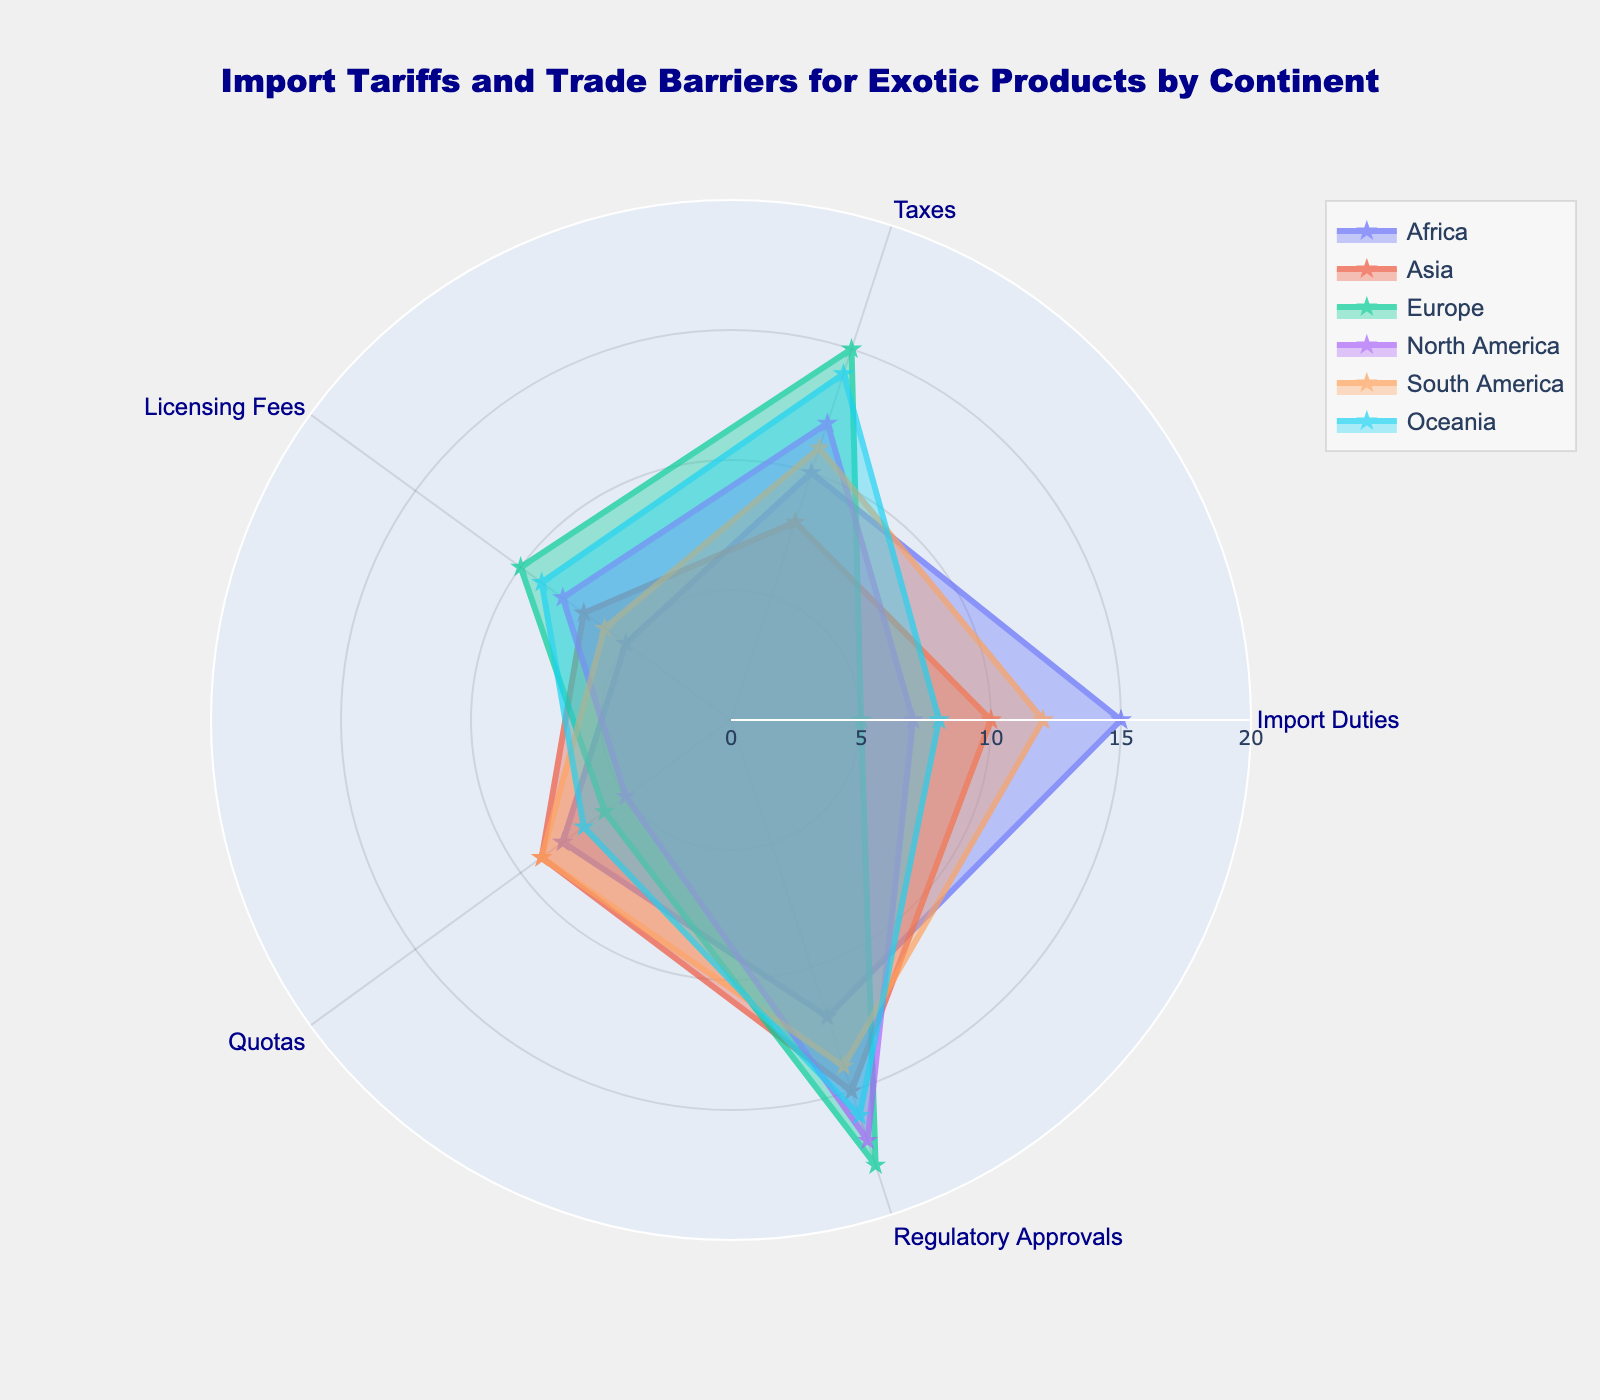What's the title of the radar chart? The title is usually located at the top of the figure. By reading the text there, we can identify it. The chart's title is: "Import Tariffs and Trade Barriers for Exotic Products by Continent".
Answer: Import Tariffs and Trade Barriers for Exotic Products by Continent Which continent has the highest Regulatory Approvals value? Look at the data points or lines corresponding to the Regulatory Approvals axis to see which continent's data reaches the highest value. Europe has the highest value at 18.
Answer: Europe How do Import Duties for Asia compare to those for Europe? Examine the axis corresponding to Import Duties and the values for both Asia and Europe. Asia has an Import Duties value of 10, while Europe has a value of 5. Thus, Asia has higher Import Duties than Europe.
Answer: Asia has higher duties What is the average of the Quotas values for all continents shown? Add up all the Quotas values (8 for Africa, 9 for Asia, 6 for Europe, 5 for North America, 9 for South America, and 7 for Oceania), then divide by the number of continents (6). (8 + 9 + 6 + 5 + 9 + 7) / 6 = 44 / 6 = 7.33.
Answer: 7.33 Which continent has the least variation among its values for all categories? Calculate the range (max value - min value) for each continent's data. Least variation will be the smallest range. Africa's values are 15, 10, 5, 8, 12; range is 10. Other ranges: Asia (8), Europe (13), North America (12), South America (5), Oceania (8). So, South America has the lowest variation.
Answer: South America How many categories does the radar chart display? Count the number of labels or spokes in the radar chart. They are Import Duties, Taxes, Licensing Fees, Quotas, and Regulatory Approvals. There are 5 categories.
Answer: 5 Between which two continents is the difference in Licensing Fees the greatest? Determine the Licensing Fees values for all continents: Africa (5), Asia (7), Europe (10), North America (8), South America (6), Oceania (9). The greatest difference is between Europe (10) and Africa (5), which is 5.
Answer: Europe and Africa Which two continents have the closest values for Taxes? Compare the Taxes values: Africa (10), Asia (8), Europe (15), North America (12), South America (11), Oceania (14). Africa and Asia have the closest values with a difference of 2 (10 - 8 = 2).
Answer: Africa and Asia What is the total sum of the Regulatory Approvals values for all continents? Add up the Regulatory Approvals values for each continent (Africa: 12, Asia: 15, Europe: 18, North America: 17, South America: 14, Oceania: 16). The total is 12 + 15 + 18 + 17 + 14 + 16 = 92.
Answer: 92 Which continent displays the most balanced (average) level of barriers overall? Calculate the average for each continent and determine the one closest to an even distribution. Africa: 10, Asia: 9.8, Europe: 10.8, North America: 9.8, South America: 10.4, Oceania: 10.8. Both Africa and Oceania are tied with an average barrier level of 10.8.
Answer: Africa and Oceania 